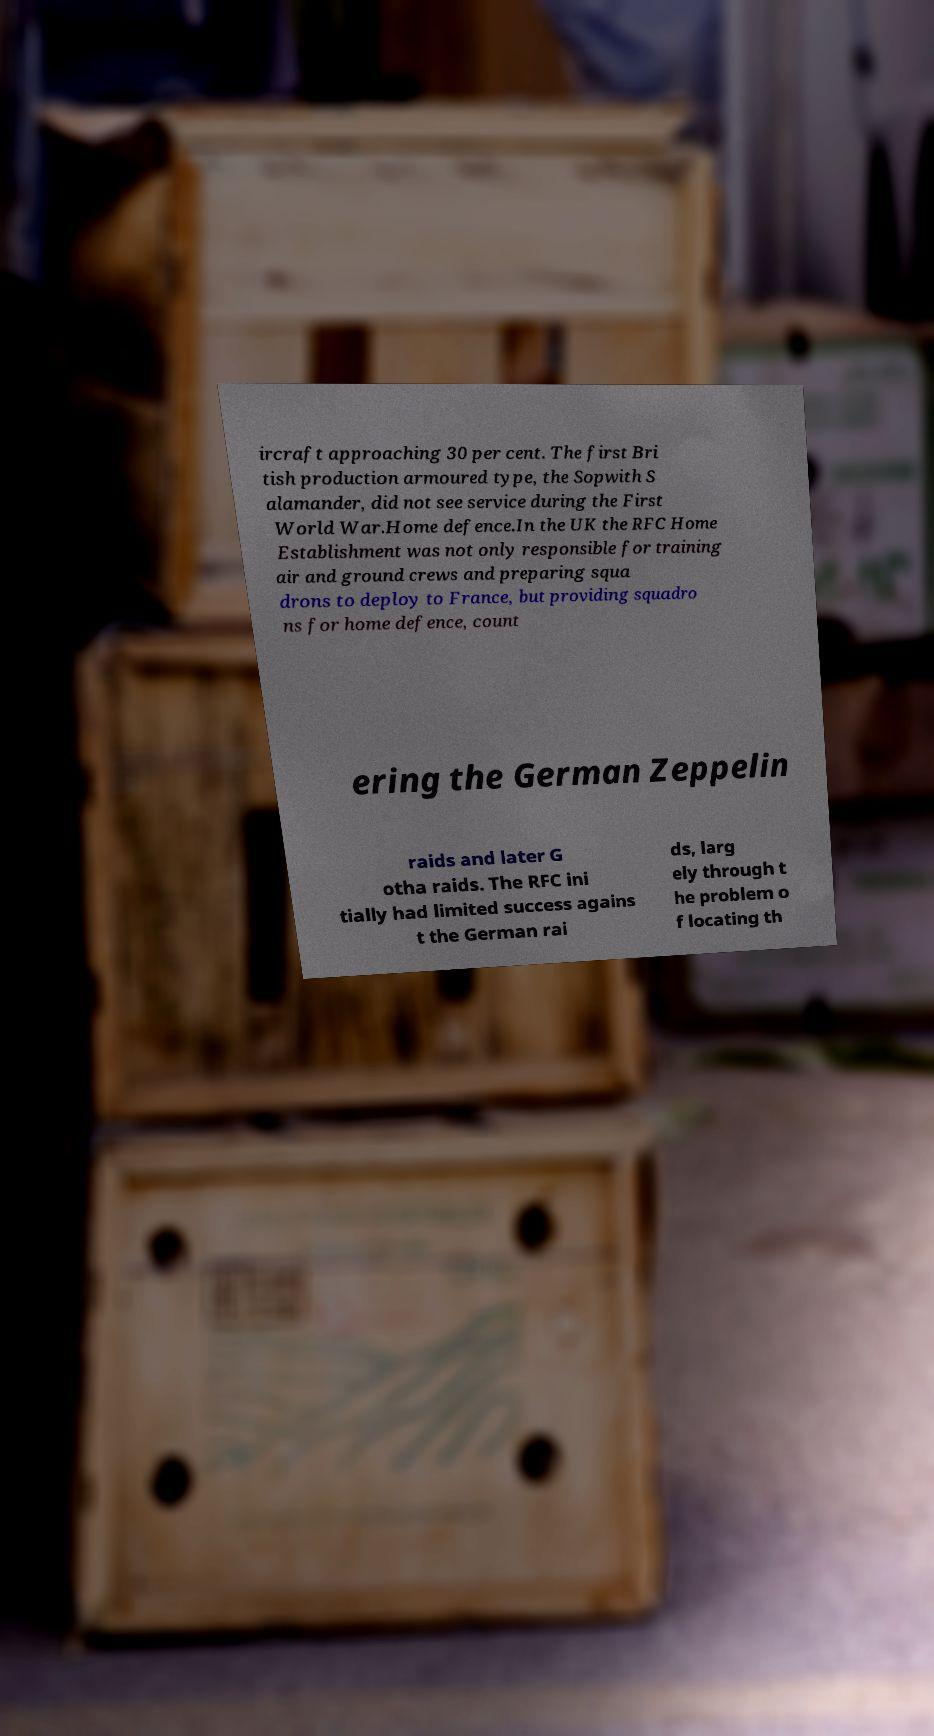Could you assist in decoding the text presented in this image and type it out clearly? ircraft approaching 30 per cent. The first Bri tish production armoured type, the Sopwith S alamander, did not see service during the First World War.Home defence.In the UK the RFC Home Establishment was not only responsible for training air and ground crews and preparing squa drons to deploy to France, but providing squadro ns for home defence, count ering the German Zeppelin raids and later G otha raids. The RFC ini tially had limited success agains t the German rai ds, larg ely through t he problem o f locating th 